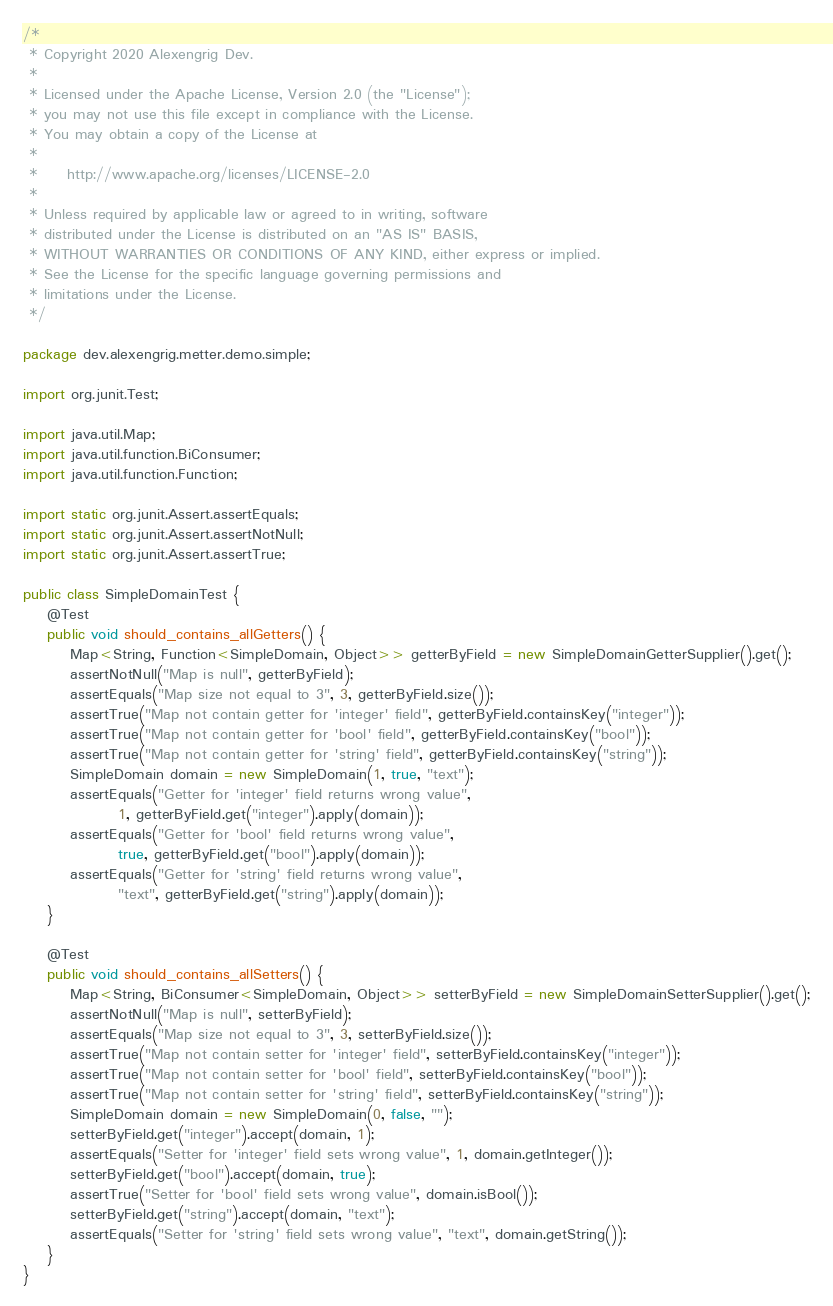<code> <loc_0><loc_0><loc_500><loc_500><_Java_>/*
 * Copyright 2020 Alexengrig Dev.
 *
 * Licensed under the Apache License, Version 2.0 (the "License");
 * you may not use this file except in compliance with the License.
 * You may obtain a copy of the License at
 *
 *     http://www.apache.org/licenses/LICENSE-2.0
 *
 * Unless required by applicable law or agreed to in writing, software
 * distributed under the License is distributed on an "AS IS" BASIS,
 * WITHOUT WARRANTIES OR CONDITIONS OF ANY KIND, either express or implied.
 * See the License for the specific language governing permissions and
 * limitations under the License.
 */

package dev.alexengrig.metter.demo.simple;

import org.junit.Test;

import java.util.Map;
import java.util.function.BiConsumer;
import java.util.function.Function;

import static org.junit.Assert.assertEquals;
import static org.junit.Assert.assertNotNull;
import static org.junit.Assert.assertTrue;

public class SimpleDomainTest {
    @Test
    public void should_contains_allGetters() {
        Map<String, Function<SimpleDomain, Object>> getterByField = new SimpleDomainGetterSupplier().get();
        assertNotNull("Map is null", getterByField);
        assertEquals("Map size not equal to 3", 3, getterByField.size());
        assertTrue("Map not contain getter for 'integer' field", getterByField.containsKey("integer"));
        assertTrue("Map not contain getter for 'bool' field", getterByField.containsKey("bool"));
        assertTrue("Map not contain getter for 'string' field", getterByField.containsKey("string"));
        SimpleDomain domain = new SimpleDomain(1, true, "text");
        assertEquals("Getter for 'integer' field returns wrong value",
                1, getterByField.get("integer").apply(domain));
        assertEquals("Getter for 'bool' field returns wrong value",
                true, getterByField.get("bool").apply(domain));
        assertEquals("Getter for 'string' field returns wrong value",
                "text", getterByField.get("string").apply(domain));
    }

    @Test
    public void should_contains_allSetters() {
        Map<String, BiConsumer<SimpleDomain, Object>> setterByField = new SimpleDomainSetterSupplier().get();
        assertNotNull("Map is null", setterByField);
        assertEquals("Map size not equal to 3", 3, setterByField.size());
        assertTrue("Map not contain setter for 'integer' field", setterByField.containsKey("integer"));
        assertTrue("Map not contain setter for 'bool' field", setterByField.containsKey("bool"));
        assertTrue("Map not contain setter for 'string' field", setterByField.containsKey("string"));
        SimpleDomain domain = new SimpleDomain(0, false, "");
        setterByField.get("integer").accept(domain, 1);
        assertEquals("Setter for 'integer' field sets wrong value", 1, domain.getInteger());
        setterByField.get("bool").accept(domain, true);
        assertTrue("Setter for 'bool' field sets wrong value", domain.isBool());
        setterByField.get("string").accept(domain, "text");
        assertEquals("Setter for 'string' field sets wrong value", "text", domain.getString());
    }
}</code> 